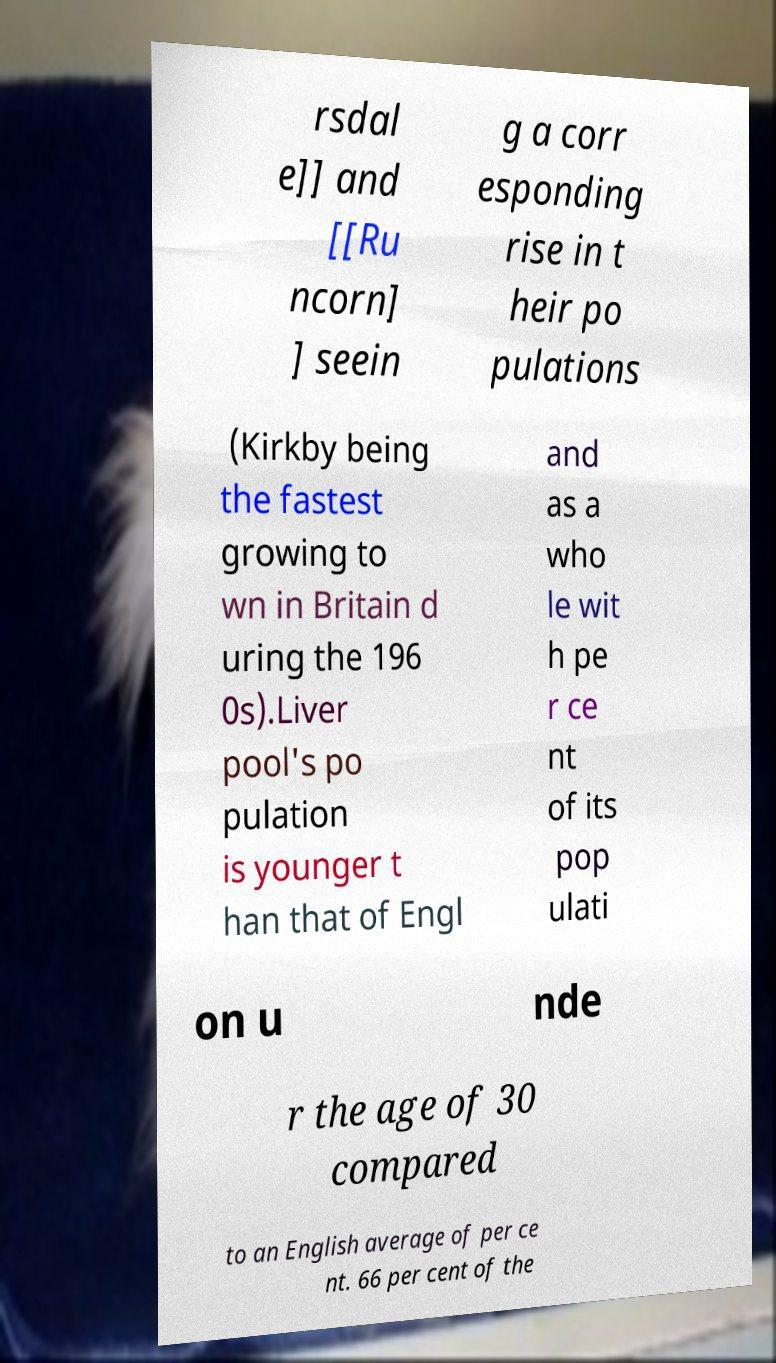Can you accurately transcribe the text from the provided image for me? rsdal e]] and [[Ru ncorn] ] seein g a corr esponding rise in t heir po pulations (Kirkby being the fastest growing to wn in Britain d uring the 196 0s).Liver pool's po pulation is younger t han that of Engl and as a who le wit h pe r ce nt of its pop ulati on u nde r the age of 30 compared to an English average of per ce nt. 66 per cent of the 